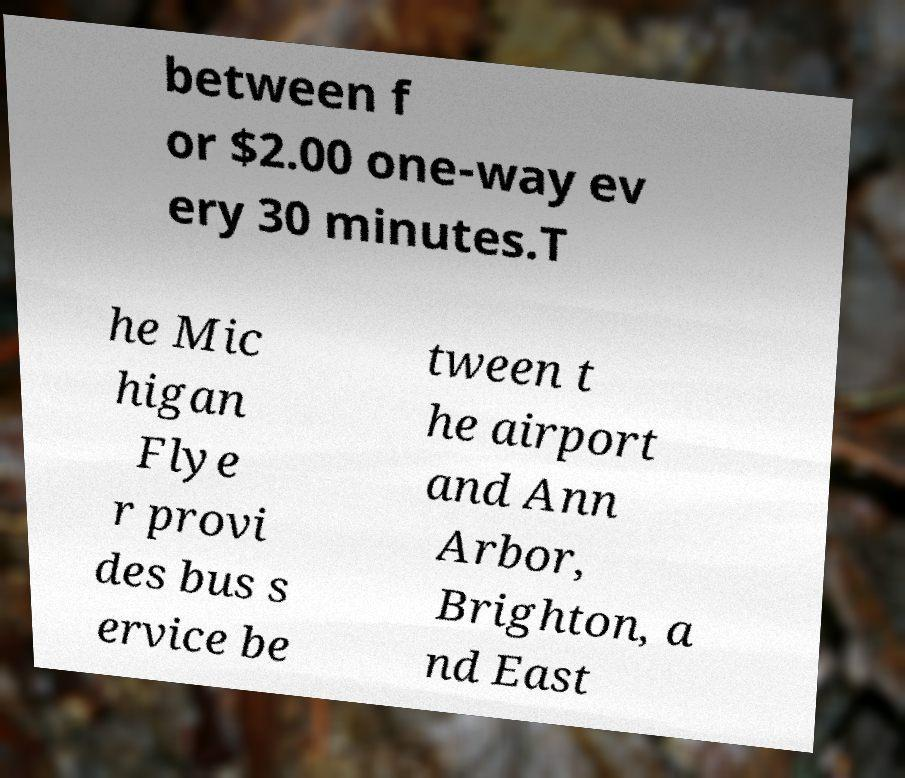Could you assist in decoding the text presented in this image and type it out clearly? between f or $2.00 one-way ev ery 30 minutes.T he Mic higan Flye r provi des bus s ervice be tween t he airport and Ann Arbor, Brighton, a nd East 